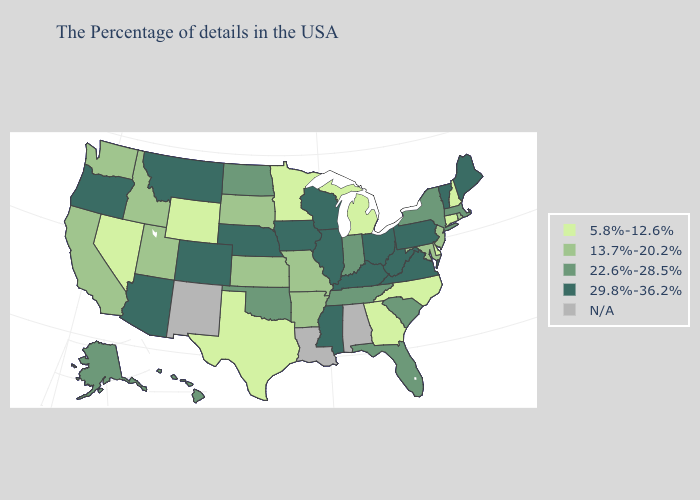Among the states that border Pennsylvania , which have the highest value?
Answer briefly. West Virginia, Ohio. What is the value of Colorado?
Quick response, please. 29.8%-36.2%. Does New York have the lowest value in the USA?
Write a very short answer. No. Does Missouri have the lowest value in the MidWest?
Quick response, please. No. Name the states that have a value in the range N/A?
Write a very short answer. Alabama, Louisiana, New Mexico. What is the value of Iowa?
Keep it brief. 29.8%-36.2%. What is the lowest value in states that border California?
Write a very short answer. 5.8%-12.6%. Does the map have missing data?
Write a very short answer. Yes. Among the states that border West Virginia , does Pennsylvania have the lowest value?
Short answer required. No. Among the states that border Vermont , which have the highest value?
Give a very brief answer. Massachusetts, New York. Does New Hampshire have the lowest value in the Northeast?
Be succinct. Yes. What is the lowest value in the MidWest?
Write a very short answer. 5.8%-12.6%. What is the value of Ohio?
Answer briefly. 29.8%-36.2%. Name the states that have a value in the range N/A?
Be succinct. Alabama, Louisiana, New Mexico. What is the value of Massachusetts?
Be succinct. 22.6%-28.5%. 